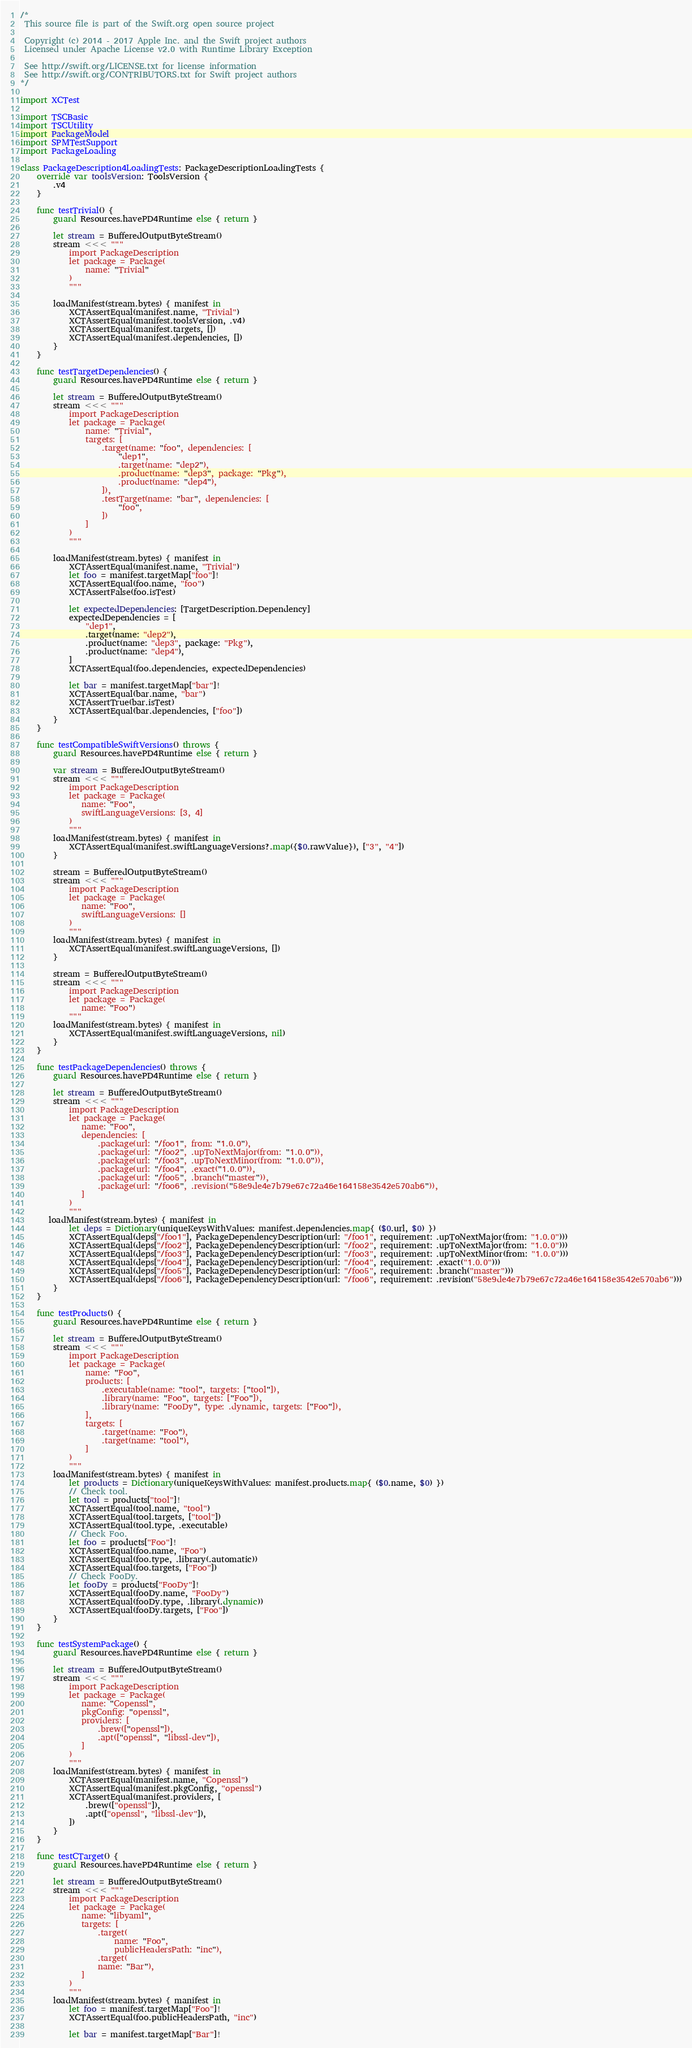Convert code to text. <code><loc_0><loc_0><loc_500><loc_500><_Swift_>/*
 This source file is part of the Swift.org open source project

 Copyright (c) 2014 - 2017 Apple Inc. and the Swift project authors
 Licensed under Apache License v2.0 with Runtime Library Exception

 See http://swift.org/LICENSE.txt for license information
 See http://swift.org/CONTRIBUTORS.txt for Swift project authors
*/

import XCTest

import TSCBasic
import TSCUtility
import PackageModel
import SPMTestSupport
import PackageLoading

class PackageDescription4LoadingTests: PackageDescriptionLoadingTests {
    override var toolsVersion: ToolsVersion {
        .v4
    }

    func testTrivial() {
        guard Resources.havePD4Runtime else { return }

        let stream = BufferedOutputByteStream()
        stream <<< """
            import PackageDescription
            let package = Package(
                name: "Trivial"
            )
            """

        loadManifest(stream.bytes) { manifest in
            XCTAssertEqual(manifest.name, "Trivial")
            XCTAssertEqual(manifest.toolsVersion, .v4)
            XCTAssertEqual(manifest.targets, [])
            XCTAssertEqual(manifest.dependencies, [])
        }
    }

    func testTargetDependencies() {
        guard Resources.havePD4Runtime else { return }

        let stream = BufferedOutputByteStream()
        stream <<< """
            import PackageDescription
            let package = Package(
                name: "Trivial",
                targets: [
                    .target(name: "foo", dependencies: [
                        "dep1",
                        .target(name: "dep2"),
                        .product(name: "dep3", package: "Pkg"),
                        .product(name: "dep4"),
                    ]),
                    .testTarget(name: "bar", dependencies: [
                        "foo",
                    ])
                ]
            )
            """

        loadManifest(stream.bytes) { manifest in
            XCTAssertEqual(manifest.name, "Trivial")
            let foo = manifest.targetMap["foo"]!
            XCTAssertEqual(foo.name, "foo")
            XCTAssertFalse(foo.isTest)

            let expectedDependencies: [TargetDescription.Dependency]
            expectedDependencies = [
                "dep1",
                .target(name: "dep2"),
                .product(name: "dep3", package: "Pkg"),
                .product(name: "dep4"),
            ]
            XCTAssertEqual(foo.dependencies, expectedDependencies)

            let bar = manifest.targetMap["bar"]!
            XCTAssertEqual(bar.name, "bar")
            XCTAssertTrue(bar.isTest)
            XCTAssertEqual(bar.dependencies, ["foo"])
        }
    }

    func testCompatibleSwiftVersions() throws {
        guard Resources.havePD4Runtime else { return }

        var stream = BufferedOutputByteStream()
        stream <<< """
            import PackageDescription
            let package = Package(
               name: "Foo",
               swiftLanguageVersions: [3, 4]
            )
            """
        loadManifest(stream.bytes) { manifest in
            XCTAssertEqual(manifest.swiftLanguageVersions?.map({$0.rawValue}), ["3", "4"])
        }

        stream = BufferedOutputByteStream()
        stream <<< """
            import PackageDescription
            let package = Package(
               name: "Foo",
               swiftLanguageVersions: []
            )
            """
        loadManifest(stream.bytes) { manifest in
            XCTAssertEqual(manifest.swiftLanguageVersions, [])
        }

        stream = BufferedOutputByteStream()
        stream <<< """
            import PackageDescription
            let package = Package(
               name: "Foo")
            """
        loadManifest(stream.bytes) { manifest in
            XCTAssertEqual(manifest.swiftLanguageVersions, nil)
        }
    }

    func testPackageDependencies() throws {
        guard Resources.havePD4Runtime else { return }

        let stream = BufferedOutputByteStream()
        stream <<< """
            import PackageDescription
            let package = Package(
               name: "Foo",
               dependencies: [
                   .package(url: "/foo1", from: "1.0.0"),
                   .package(url: "/foo2", .upToNextMajor(from: "1.0.0")),
                   .package(url: "/foo3", .upToNextMinor(from: "1.0.0")),
                   .package(url: "/foo4", .exact("1.0.0")),
                   .package(url: "/foo5", .branch("master")),
                   .package(url: "/foo6", .revision("58e9de4e7b79e67c72a46e164158e3542e570ab6")),
               ]
            )
            """
       loadManifest(stream.bytes) { manifest in
            let deps = Dictionary(uniqueKeysWithValues: manifest.dependencies.map{ ($0.url, $0) })
            XCTAssertEqual(deps["/foo1"], PackageDependencyDescription(url: "/foo1", requirement: .upToNextMajor(from: "1.0.0")))
            XCTAssertEqual(deps["/foo2"], PackageDependencyDescription(url: "/foo2", requirement: .upToNextMajor(from: "1.0.0")))
            XCTAssertEqual(deps["/foo3"], PackageDependencyDescription(url: "/foo3", requirement: .upToNextMinor(from: "1.0.0")))
            XCTAssertEqual(deps["/foo4"], PackageDependencyDescription(url: "/foo4", requirement: .exact("1.0.0")))
            XCTAssertEqual(deps["/foo5"], PackageDependencyDescription(url: "/foo5", requirement: .branch("master")))
            XCTAssertEqual(deps["/foo6"], PackageDependencyDescription(url: "/foo6", requirement: .revision("58e9de4e7b79e67c72a46e164158e3542e570ab6")))
        }
    }

    func testProducts() {
        guard Resources.havePD4Runtime else { return }

        let stream = BufferedOutputByteStream()
        stream <<< """
            import PackageDescription
            let package = Package(
                name: "Foo",
                products: [
                    .executable(name: "tool", targets: ["tool"]),
                    .library(name: "Foo", targets: ["Foo"]),
                    .library(name: "FooDy", type: .dynamic, targets: ["Foo"]),
                ],
                targets: [
                    .target(name: "Foo"),
                    .target(name: "tool"),
                ]
            )
            """
        loadManifest(stream.bytes) { manifest in
            let products = Dictionary(uniqueKeysWithValues: manifest.products.map{ ($0.name, $0) })
            // Check tool.
            let tool = products["tool"]!
            XCTAssertEqual(tool.name, "tool")
            XCTAssertEqual(tool.targets, ["tool"])
            XCTAssertEqual(tool.type, .executable)
            // Check Foo.
            let foo = products["Foo"]!
            XCTAssertEqual(foo.name, "Foo")
            XCTAssertEqual(foo.type, .library(.automatic))
            XCTAssertEqual(foo.targets, ["Foo"])
            // Check FooDy.
            let fooDy = products["FooDy"]!
            XCTAssertEqual(fooDy.name, "FooDy")
            XCTAssertEqual(fooDy.type, .library(.dynamic))
            XCTAssertEqual(fooDy.targets, ["Foo"])
        }
    }

    func testSystemPackage() {
        guard Resources.havePD4Runtime else { return }

        let stream = BufferedOutputByteStream()
        stream <<< """
            import PackageDescription
            let package = Package(
               name: "Copenssl",
               pkgConfig: "openssl",
               providers: [
                   .brew(["openssl"]),
                   .apt(["openssl", "libssl-dev"]),
               ]
            )
            """
        loadManifest(stream.bytes) { manifest in
            XCTAssertEqual(manifest.name, "Copenssl")
            XCTAssertEqual(manifest.pkgConfig, "openssl")
            XCTAssertEqual(manifest.providers, [
                .brew(["openssl"]),
                .apt(["openssl", "libssl-dev"]),
            ])
        }
    }

    func testCTarget() {
        guard Resources.havePD4Runtime else { return }

        let stream = BufferedOutputByteStream()
        stream <<< """
            import PackageDescription
            let package = Package(
               name: "libyaml",
               targets: [
                   .target(
                       name: "Foo",
                       publicHeadersPath: "inc"),
                   .target(
                   name: "Bar"),
               ]
            )
            """
        loadManifest(stream.bytes) { manifest in
            let foo = manifest.targetMap["Foo"]!
            XCTAssertEqual(foo.publicHeadersPath, "inc")

            let bar = manifest.targetMap["Bar"]!</code> 